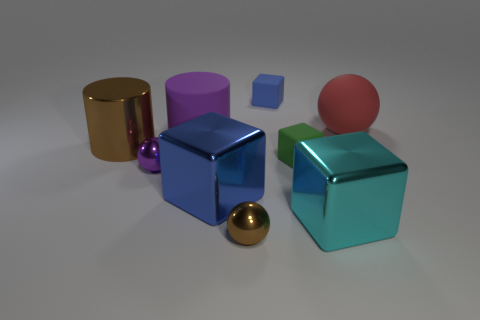Subtract all balls. How many objects are left? 6 Add 7 large red rubber balls. How many large red rubber balls exist? 8 Subtract 0 yellow balls. How many objects are left? 9 Subtract all big purple matte cylinders. Subtract all tiny metallic objects. How many objects are left? 6 Add 1 brown spheres. How many brown spheres are left? 2 